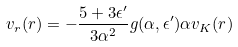Convert formula to latex. <formula><loc_0><loc_0><loc_500><loc_500>v _ { r } ( r ) = - \frac { 5 + 3 \epsilon ^ { \prime } } { 3 \alpha ^ { 2 } } g ( \alpha , \epsilon ^ { \prime } ) \alpha v _ { K } ( r )</formula> 